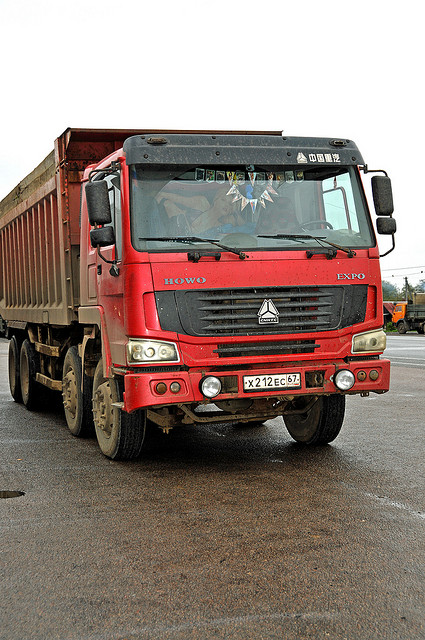<image>What is the brand name on the truck? I don't know the brand name on the truck. It could be 'howe', 'mercedes', 'chevy', 'suzuki', or 'dacia'. What brand is this truck? I am not sure what the brand of the truck is. It can be Hugo, How Expo, How, Daewoo, or Mercedes. What is the brand name on the truck? I am not sure what the brand name on the truck is. It can be seen as 'mercedes', 'chevy', 'howe', 'suzuki', or 'dacia'. What brand is this truck? It is unknown what brand this truck is. It can be seen 'hugo', 'unknown', 'how expo', 'how', 'daewoo', 'mercedes', 'cannot tell'. 